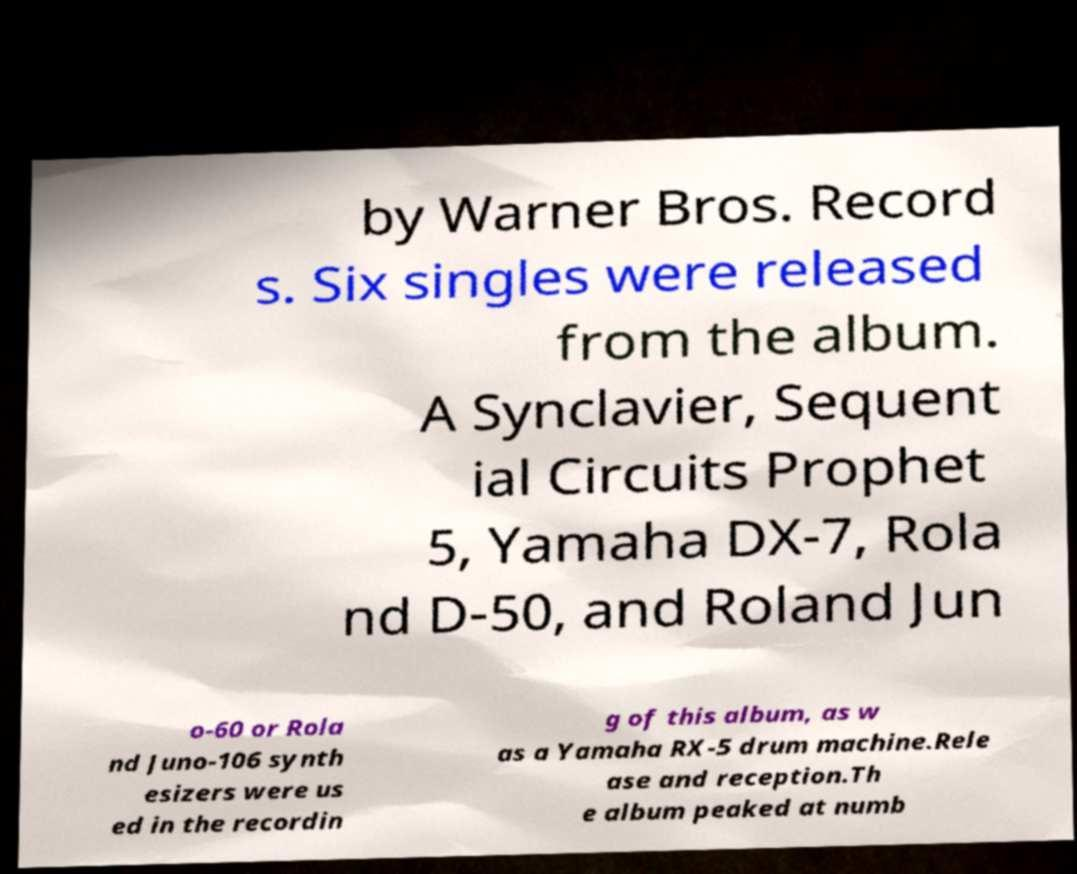Please read and relay the text visible in this image. What does it say? by Warner Bros. Record s. Six singles were released from the album. A Synclavier, Sequent ial Circuits Prophet 5, Yamaha DX-7, Rola nd D-50, and Roland Jun o-60 or Rola nd Juno-106 synth esizers were us ed in the recordin g of this album, as w as a Yamaha RX-5 drum machine.Rele ase and reception.Th e album peaked at numb 